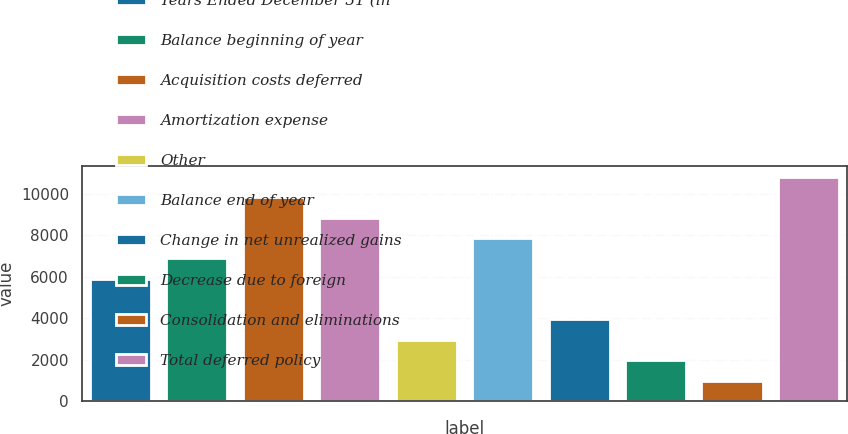Convert chart to OTSL. <chart><loc_0><loc_0><loc_500><loc_500><bar_chart><fcel>Years Ended December 31 (in<fcel>Balance beginning of year<fcel>Acquisition costs deferred<fcel>Amortization expense<fcel>Other<fcel>Balance end of year<fcel>Change in net unrealized gains<fcel>Decrease due to foreign<fcel>Consolidation and eliminations<fcel>Total deferred policy<nl><fcel>5903<fcel>6884<fcel>9827<fcel>8846<fcel>2960<fcel>7865<fcel>3941<fcel>1979<fcel>998<fcel>10808<nl></chart> 